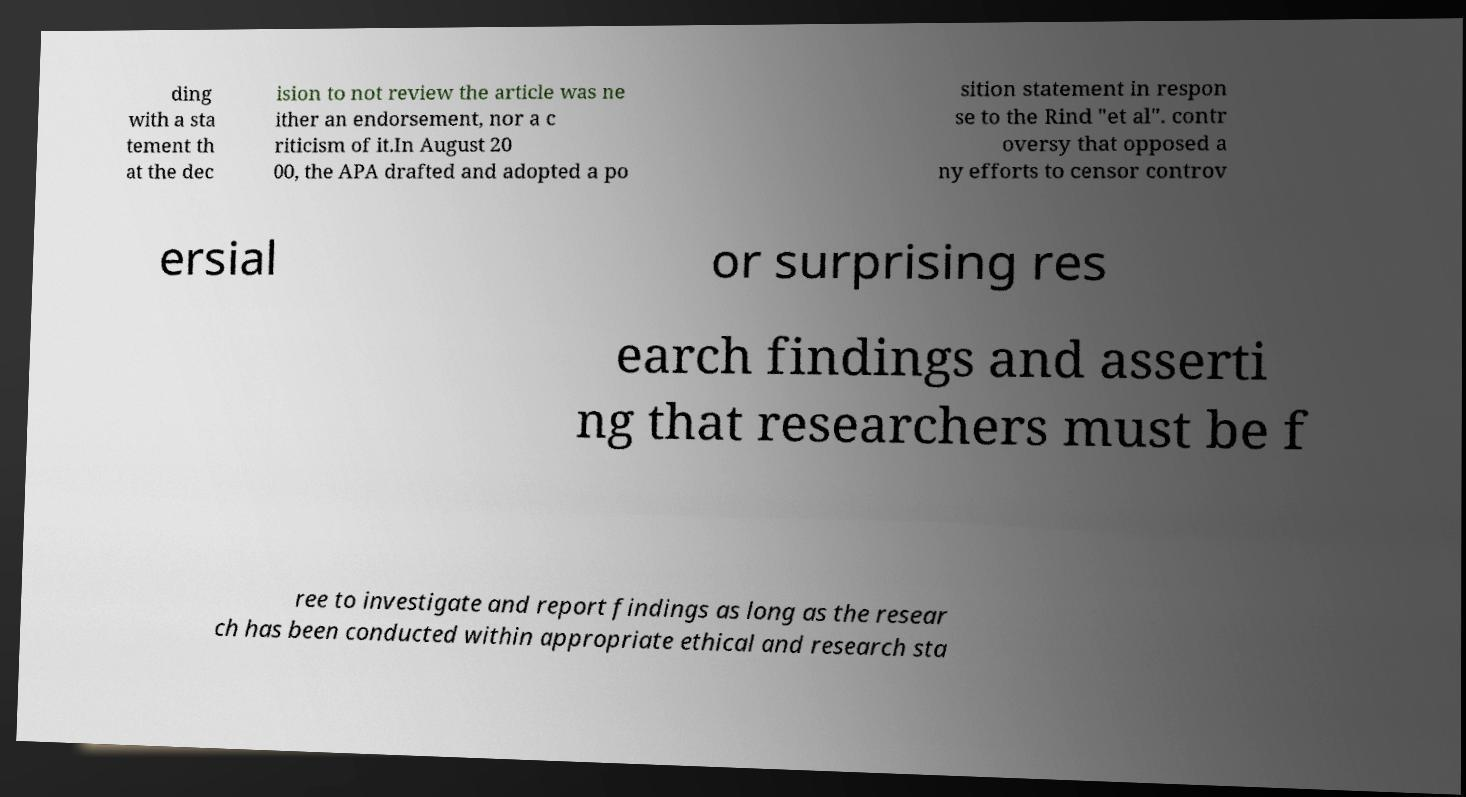There's text embedded in this image that I need extracted. Can you transcribe it verbatim? ding with a sta tement th at the dec ision to not review the article was ne ither an endorsement, nor a c riticism of it.In August 20 00, the APA drafted and adopted a po sition statement in respon se to the Rind "et al". contr oversy that opposed a ny efforts to censor controv ersial or surprising res earch findings and asserti ng that researchers must be f ree to investigate and report findings as long as the resear ch has been conducted within appropriate ethical and research sta 